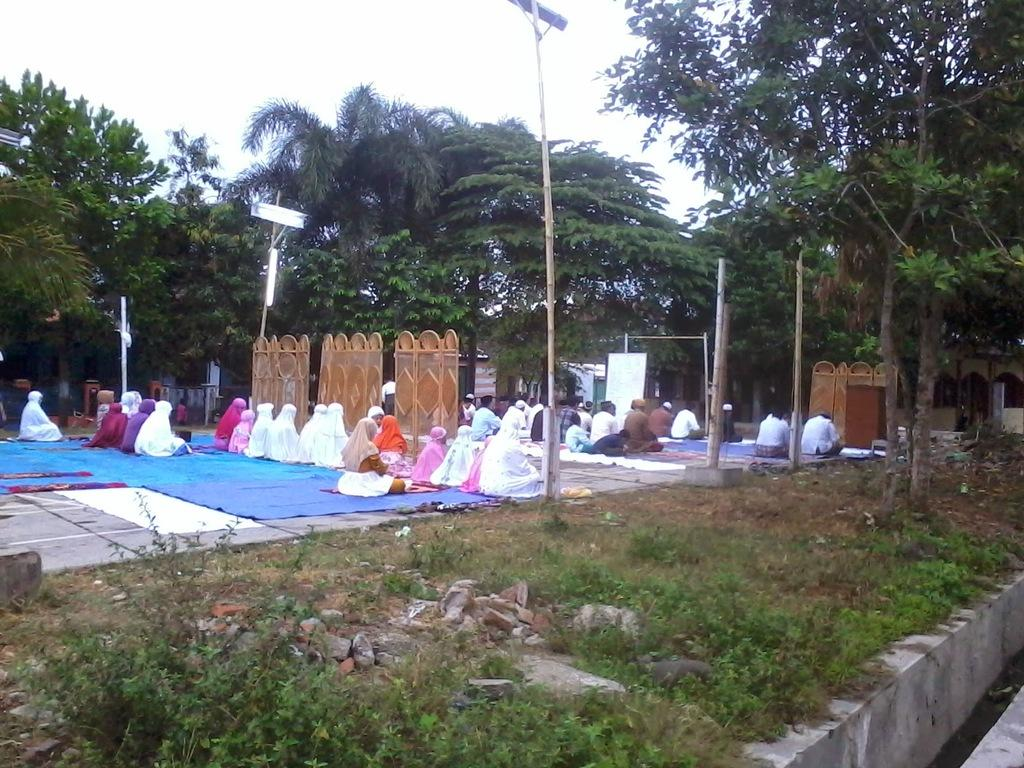What type of vegetation can be seen in the image? There are trees, grass, and plants in the image. Can you describe the people in the image? There are people in the image, but their specific actions or characteristics are not mentioned in the provided facts. What type of materials are present in the image? There are bricks, sticks, and poles in the image. What part of the natural environment is visible in the image? The sky is visible in the image. What type of mine is visible in the image? There is no mine present in the image. Can you describe the snake's attempt to climb the pole in the image? There is no snake present in the image, so it is not possible to describe any attempts to climb the pole. 